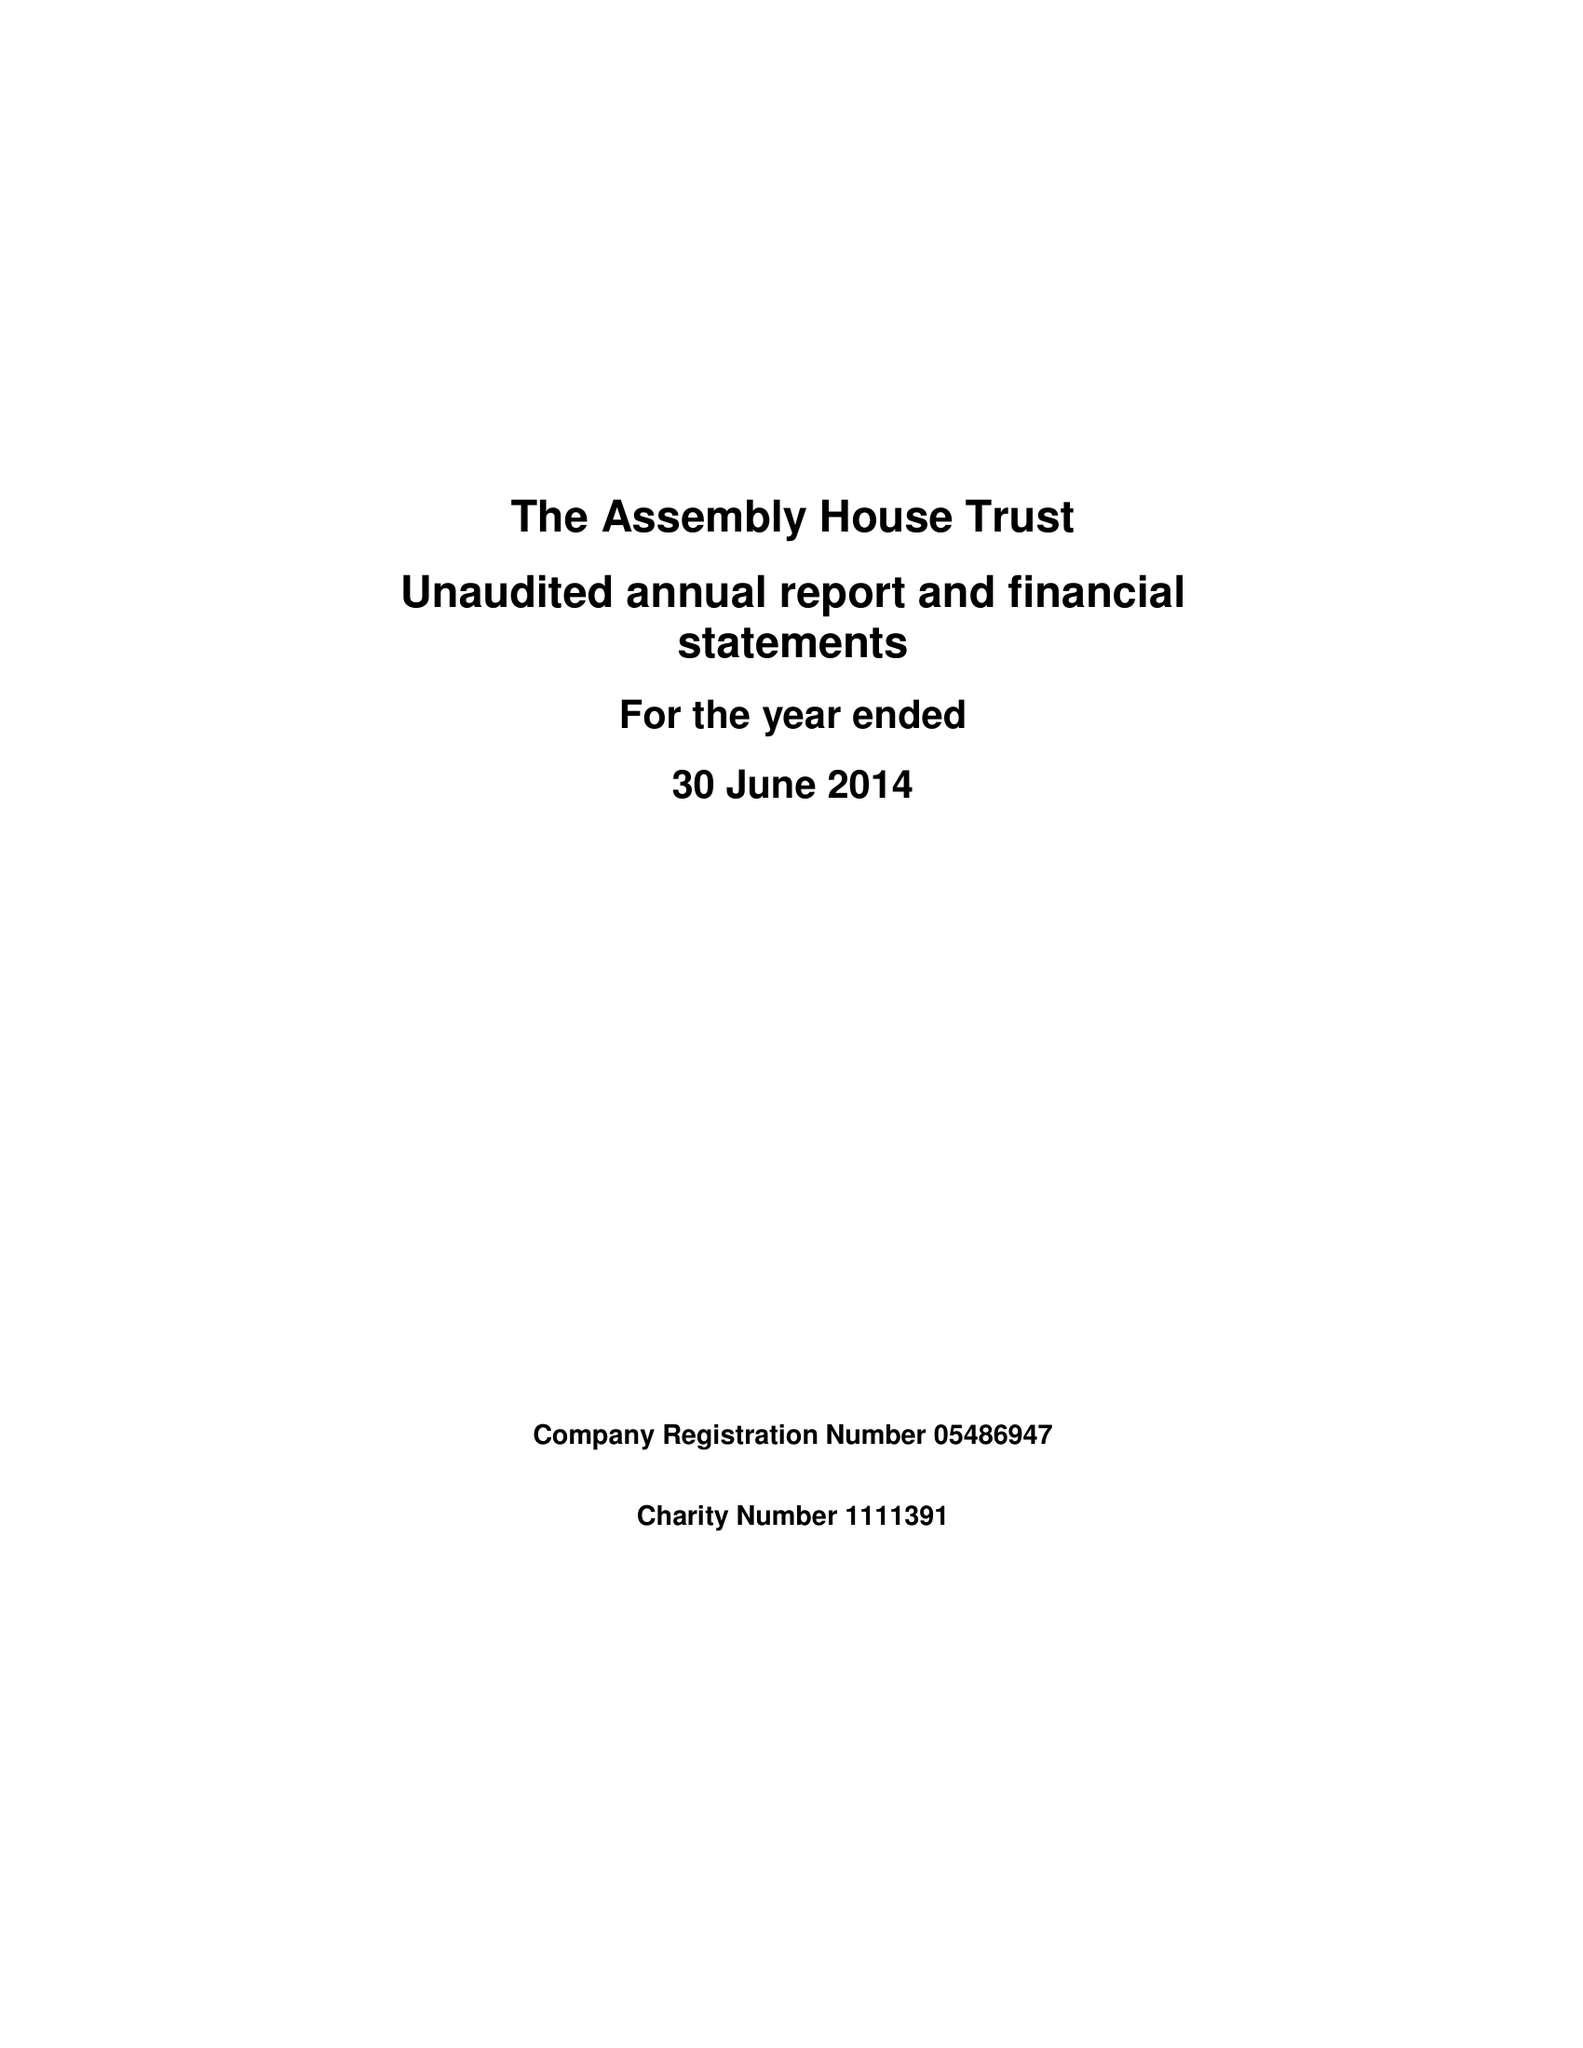What is the value for the charity_name?
Answer the question using a single word or phrase. The Assembly House Trust 